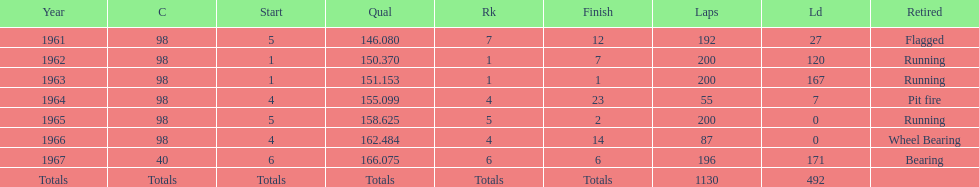How many times did he finish in the top three? 2. 